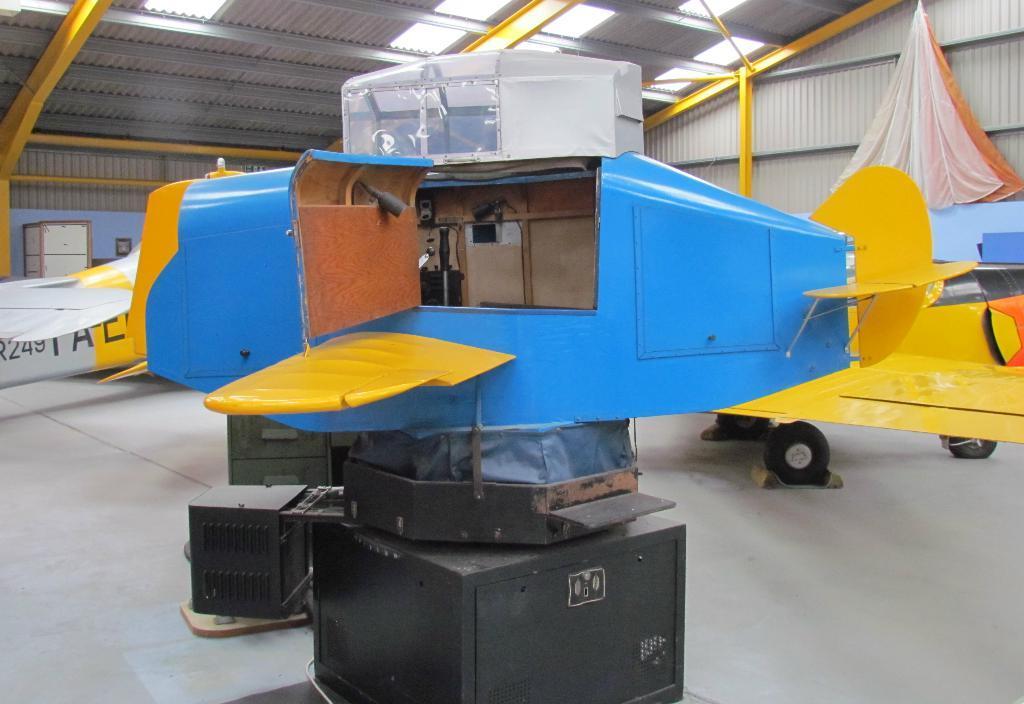How would you summarize this image in a sentence or two? In this image we can see a model of aircraft on a stand. In the back we can see an object with tires. On the ceiling there are lights. In the back there is a wall. Also there is a box. On the right side there is a cloth. 